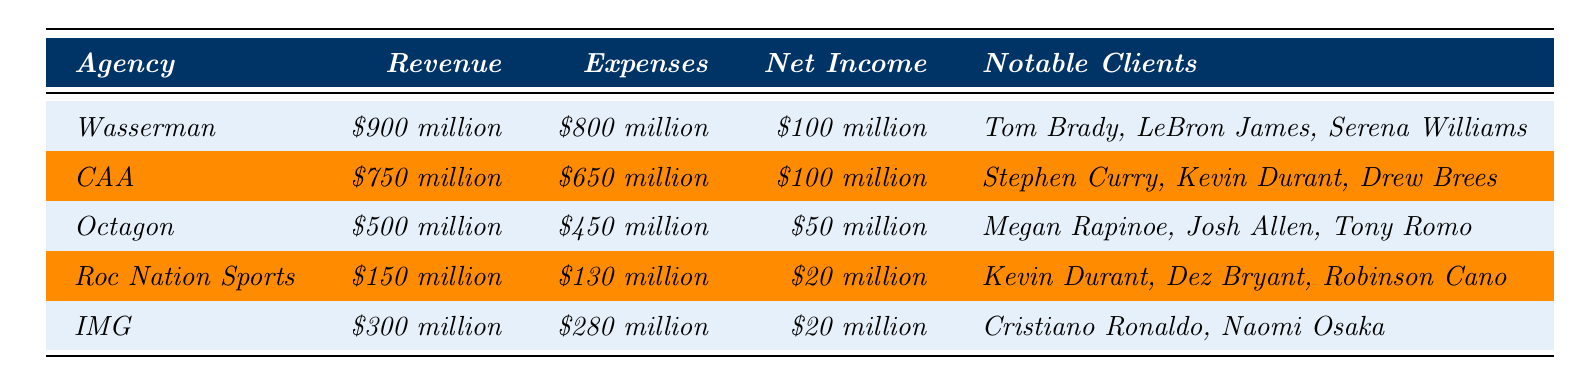What is the net income of Wasserman? The table lists Wasserman's net income in the respective row. It states that Wasserman's net income is $100 million.
Answer: $100 million Which agency has the highest revenue? By comparing the revenue figures in the table, Wasserman has the highest revenue at $900 million.
Answer: Wasserman What is the total revenue of all agencies combined? To find the total revenue, add each agency's revenue: $900 million + $750 million + $500 million + $150 million + $300 million = $2600 million.
Answer: $2.6 billion Does Roc Nation Sports have higher expenses than IMG? Roc Nation Sports has expenses of $130 million while IMG has expenses of $280 million. Since $130 million is less than $280 million, the answer is no.
Answer: No What is the difference in net income between CAA and Octagon? CAA's net income is $100 million and Octagon's is $50 million. Subtract the two values: $100 million - $50 million = $50 million.
Answer: $50 million What agency has the least amount of net income? A quick glance at the net income column shows Roc Nation Sports and IMG both have $20 million. However, since Roc Nation Sports is mentioned first in the table, it is considered the least by listing order.
Answer: Roc Nation Sports What is the average net income of the agencies listed? To calculate the average, sum the net incomes: ($100 million + $100 million + $50 million + $20 million + $20 million = $290 million). Then divide by the number of agencies (5): $290 million / 5 = $58 million.
Answer: $58 million Which agency represents Kevin Durant? The table notes that two agencies represent Kevin Durant: CAA and Roc Nation Sports. Therefore, both agencies represent him.
Answer: CAA and Roc Nation Sports Is the revenue of Octagon greater than that of IMG? Octagon has revenue of $500 million, while IMG has revenue of $300 million. Since $500 million is greater than $300 million, the answer is yes.
Answer: Yes What percentage of their revenue does IMG spend on expenses? To find the percentage, divide IMG's expenses ($280 million) by its revenue ($300 million) and then multiply by 100: ($280 million / $300 million) * 100 = 93.33%.
Answer: 93.33% 